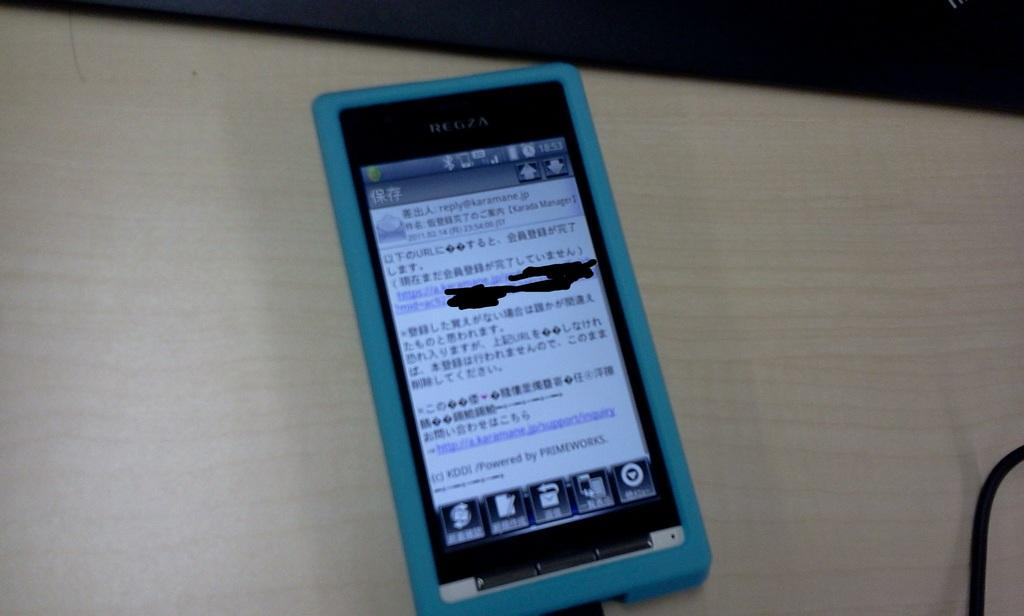<image>
Create a compact narrative representing the image presented. A phone screen displays the time of 18:53. 